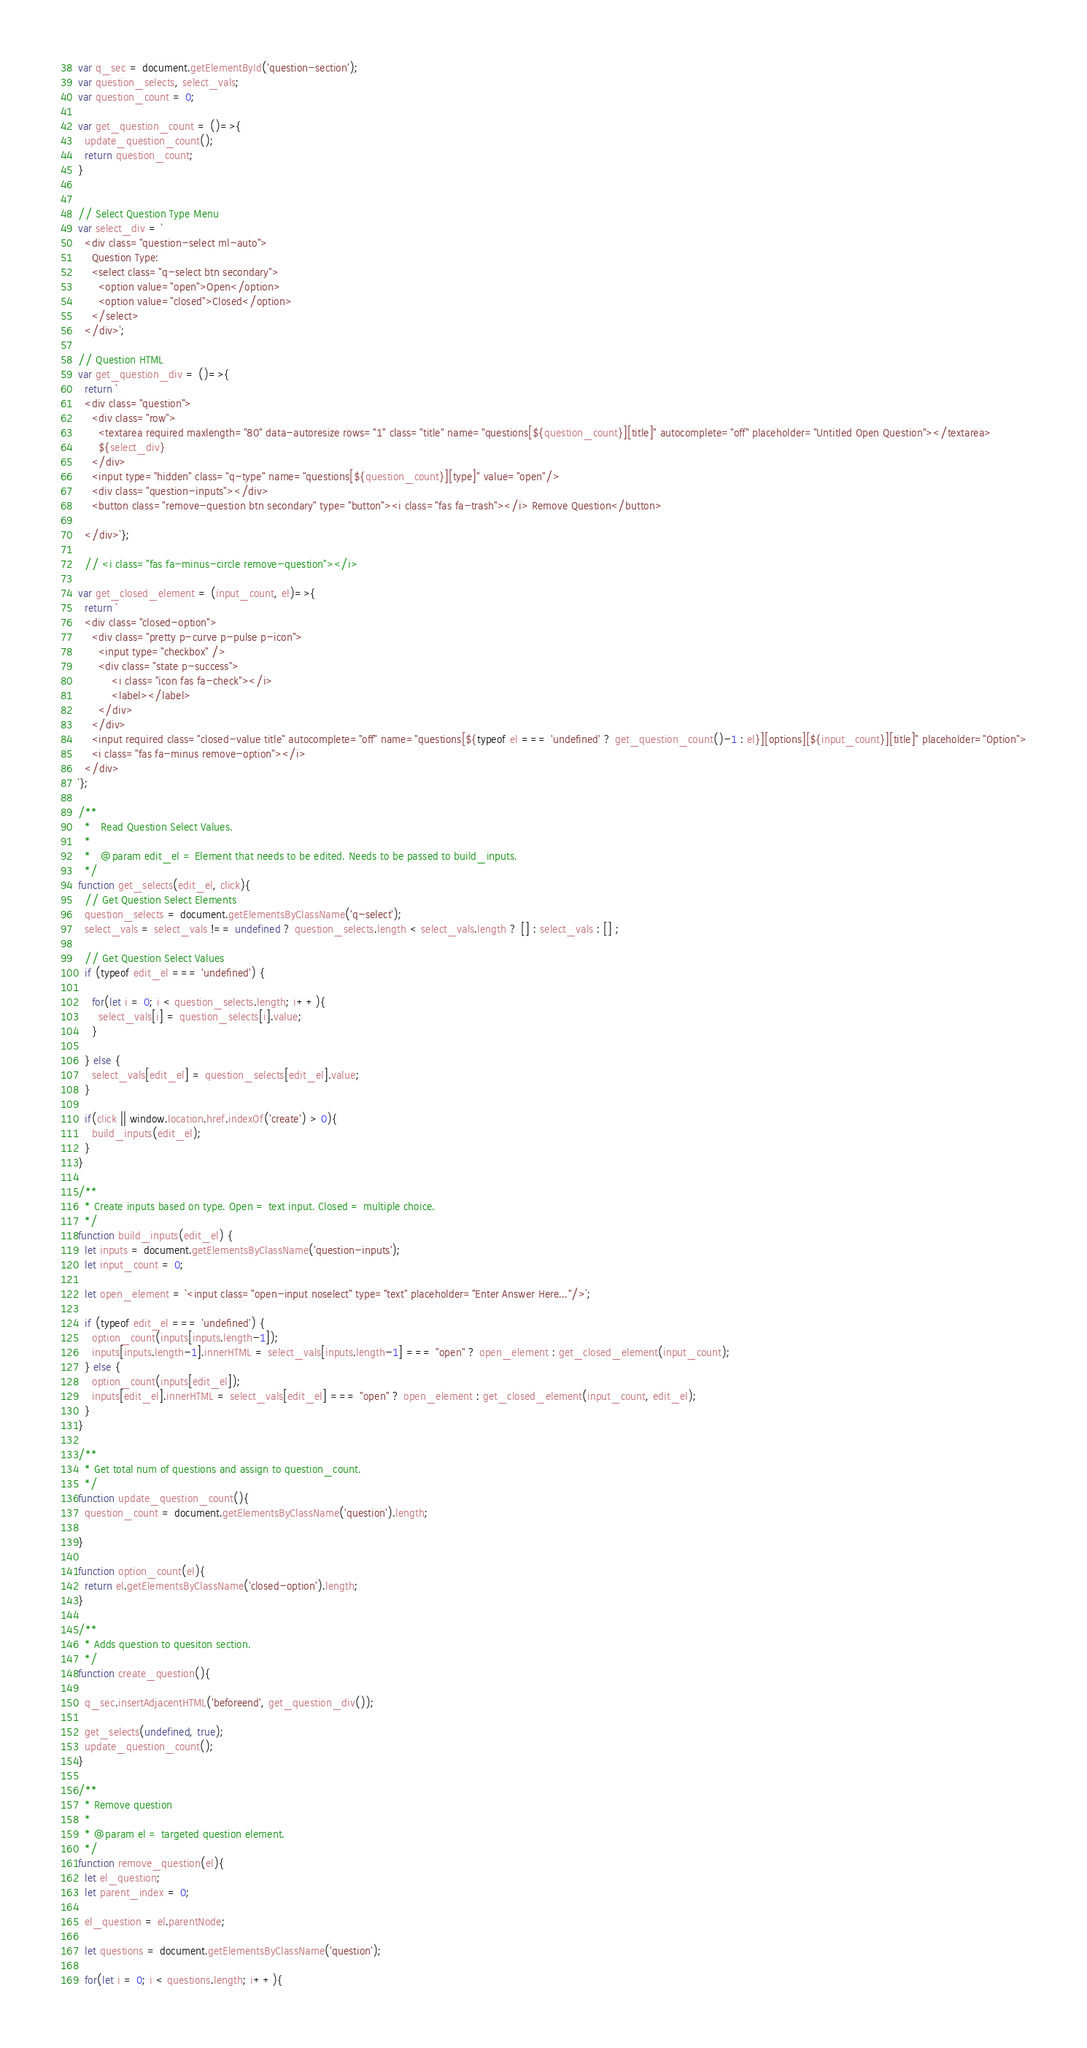Convert code to text. <code><loc_0><loc_0><loc_500><loc_500><_JavaScript_>
var q_sec = document.getElementById('question-section');
var question_selects, select_vals;
var question_count = 0;

var get_question_count = ()=>{
  update_question_count();
  return question_count;
}


// Select Question Type Menu
var select_div = `
  <div class="question-select ml-auto">
    Question Type:
    <select class="q-select btn secondary">
      <option value="open">Open</option>
      <option value="closed">Closed</option>
    </select>
  </div>`;

// Question HTML
var get_question_div = ()=>{
  return `
  <div class="question">
    <div class="row">
      <textarea required maxlength="80" data-autoresize rows="1" class="title" name="questions[${question_count}][title]" autocomplete="off" placeholder="Untitled Open Question"></textarea>
      ${select_div}
    </div>
    <input type="hidden" class="q-type" name="questions[${question_count}][type]" value="open"/>
    <div class="question-inputs"></div>
    <button class="remove-question btn secondary" type="button"><i class="fas fa-trash"></i> Remove Question</button>

  </div>`};

  // <i class="fas fa-minus-circle remove-question"></i>

var get_closed_element = (input_count, el)=>{
  return `
  <div class="closed-option">
    <div class="pretty p-curve p-pulse p-icon">
      <input type="checkbox" />
      <div class="state p-success">
          <i class="icon fas fa-check"></i>
          <label></label>
      </div>
    </div>
    <input required class="closed-value title" autocomplete="off" name="questions[${typeof el === 'undefined' ? get_question_count()-1 : el}][options][${input_count}][title]" placeholder="Option">
    <i class="fas fa-minus remove-option"></i>
  </div>
`};

/**
  *   Read Question Select Values.
  *
  *   @param edit_el = Element that needs to be edited. Needs to be passed to build_inputs.
  */
function get_selects(edit_el, click){
  // Get Question Select Elements
  question_selects = document.getElementsByClassName('q-select');
  select_vals = select_vals !== undefined ? question_selects.length < select_vals.length ? [] : select_vals : [] ;

  // Get Question Select Values
  if (typeof edit_el === 'undefined') {

    for(let i = 0; i < question_selects.length; i++){
      select_vals[i] = question_selects[i].value;
    }

  } else {
    select_vals[edit_el] = question_selects[edit_el].value;
  }

  if(click || window.location.href.indexOf('create') > 0){
    build_inputs(edit_el);
  }
}

/**
  * Create inputs based on type. Open = text input. Closed = multiple choice.
  */
function build_inputs(edit_el) {
  let inputs = document.getElementsByClassName('question-inputs');
  let input_count = 0;

  let open_element = `<input class="open-input noselect" type="text" placeholder="Enter Answer Here..."/>`;

  if (typeof edit_el === 'undefined') {
    option_count(inputs[inputs.length-1]);
    inputs[inputs.length-1].innerHTML = select_vals[inputs.length-1] === "open" ? open_element : get_closed_element(input_count);
  } else {
    option_count(inputs[edit_el]);
    inputs[edit_el].innerHTML = select_vals[edit_el] === "open" ? open_element : get_closed_element(input_count, edit_el);
  }
}

/**
  * Get total num of questions and assign to question_count.
  */
function update_question_count(){
  question_count = document.getElementsByClassName('question').length;

}

function option_count(el){
  return el.getElementsByClassName('closed-option').length;
}

/**
  * Adds question to quesiton section.
  */
function create_question(){

  q_sec.insertAdjacentHTML('beforeend', get_question_div());

  get_selects(undefined, true);
  update_question_count();
}

/**
  * Remove question
  *
  * @param el = targeted question element.
  */
function remove_question(el){
  let el_question;
  let parent_index = 0;

  el_question = el.parentNode;

  let questions = document.getElementsByClassName('question');

  for(let i = 0; i < questions.length; i++){</code> 